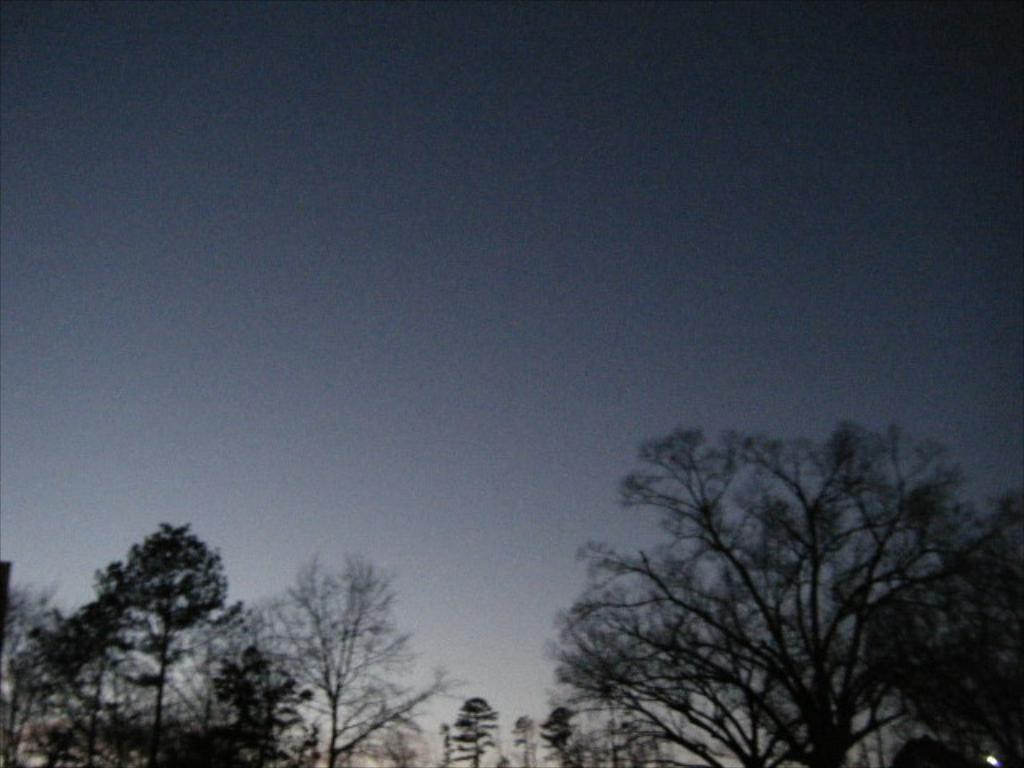What type of vegetation is present at the bottom of the image? There are trees at the bottom of the image. What can be seen in the background of the image? The sky is visible in the background of the image. How many friends are participating in the feast in the image? There is no feast or friends present in the image; it only features trees and the sky. 